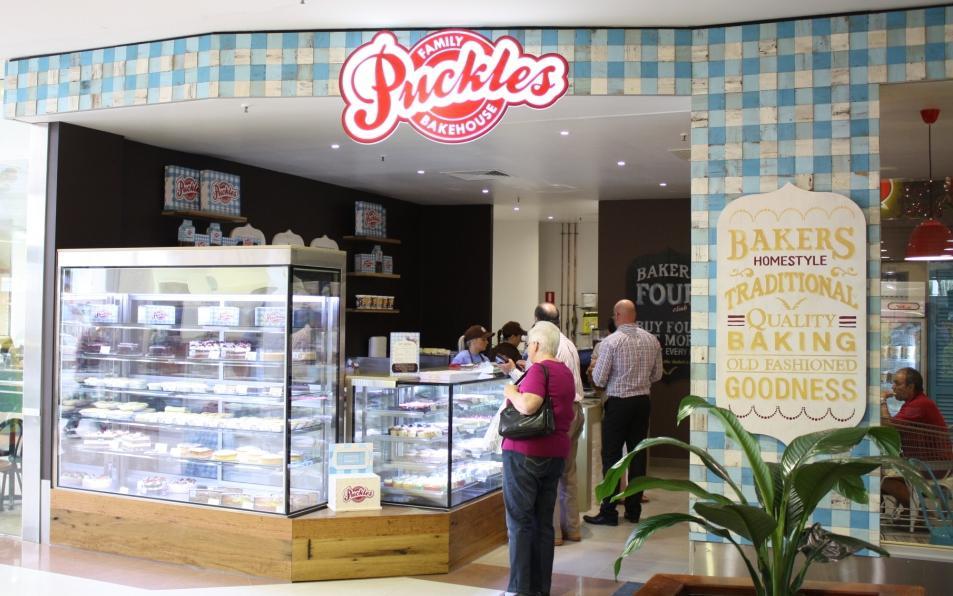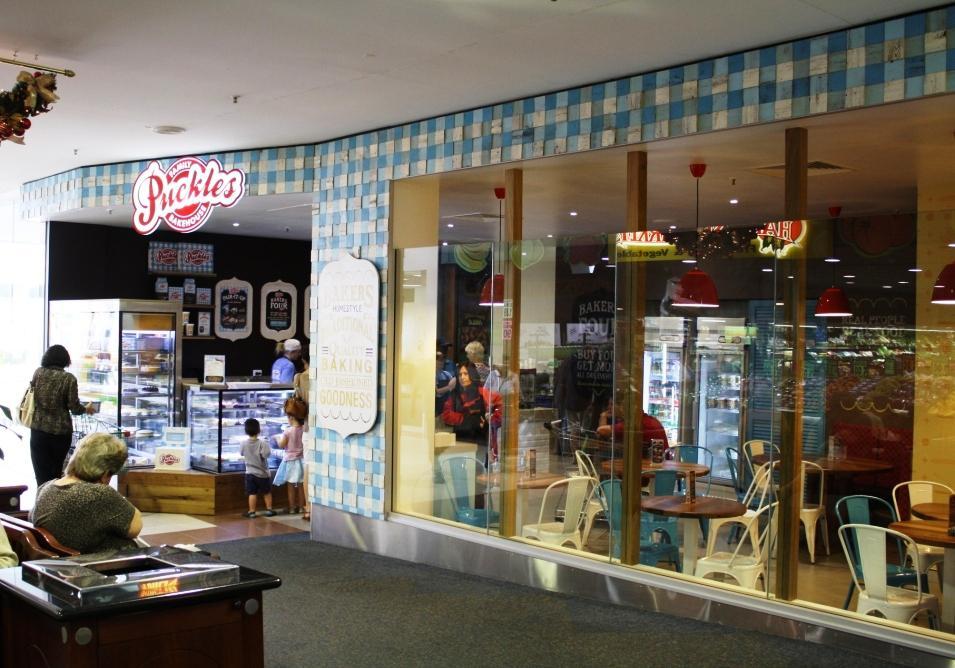The first image is the image on the left, the second image is the image on the right. Evaluate the accuracy of this statement regarding the images: "Both images show bakeries with the same name.". Is it true? Answer yes or no. Yes. The first image is the image on the left, the second image is the image on the right. For the images shown, is this caption "People are standing in front of a restaurant." true? Answer yes or no. Yes. 